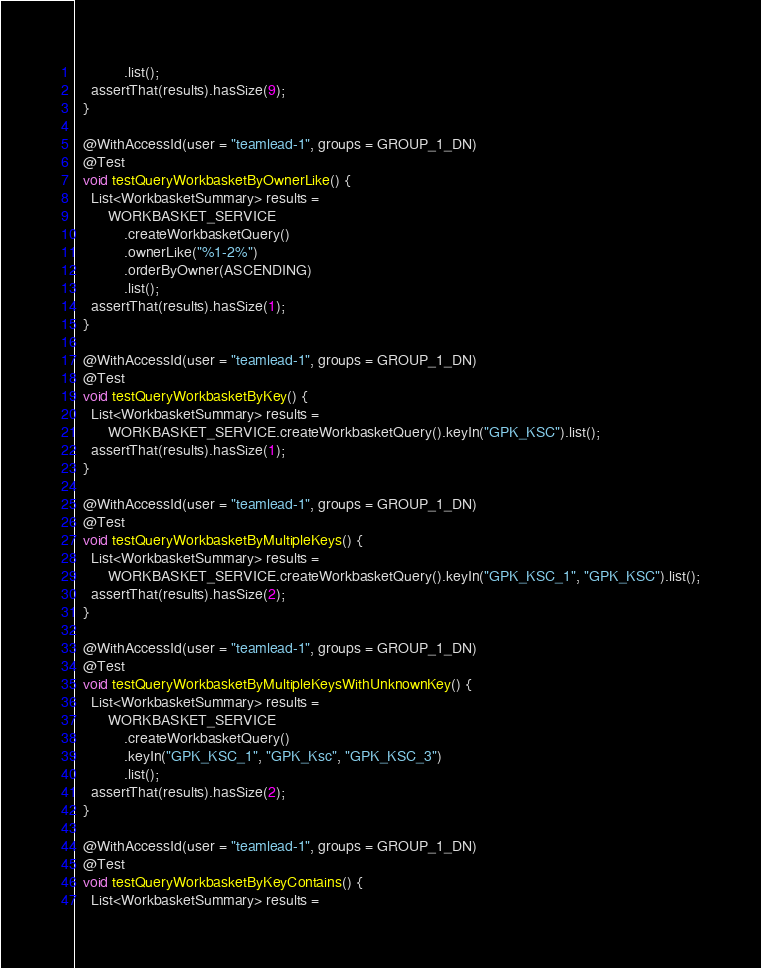<code> <loc_0><loc_0><loc_500><loc_500><_Java_>            .list();
    assertThat(results).hasSize(9);
  }

  @WithAccessId(user = "teamlead-1", groups = GROUP_1_DN)
  @Test
  void testQueryWorkbasketByOwnerLike() {
    List<WorkbasketSummary> results =
        WORKBASKET_SERVICE
            .createWorkbasketQuery()
            .ownerLike("%1-2%")
            .orderByOwner(ASCENDING)
            .list();
    assertThat(results).hasSize(1);
  }

  @WithAccessId(user = "teamlead-1", groups = GROUP_1_DN)
  @Test
  void testQueryWorkbasketByKey() {
    List<WorkbasketSummary> results =
        WORKBASKET_SERVICE.createWorkbasketQuery().keyIn("GPK_KSC").list();
    assertThat(results).hasSize(1);
  }

  @WithAccessId(user = "teamlead-1", groups = GROUP_1_DN)
  @Test
  void testQueryWorkbasketByMultipleKeys() {
    List<WorkbasketSummary> results =
        WORKBASKET_SERVICE.createWorkbasketQuery().keyIn("GPK_KSC_1", "GPK_KSC").list();
    assertThat(results).hasSize(2);
  }

  @WithAccessId(user = "teamlead-1", groups = GROUP_1_DN)
  @Test
  void testQueryWorkbasketByMultipleKeysWithUnknownKey() {
    List<WorkbasketSummary> results =
        WORKBASKET_SERVICE
            .createWorkbasketQuery()
            .keyIn("GPK_KSC_1", "GPK_Ksc", "GPK_KSC_3")
            .list();
    assertThat(results).hasSize(2);
  }

  @WithAccessId(user = "teamlead-1", groups = GROUP_1_DN)
  @Test
  void testQueryWorkbasketByKeyContains() {
    List<WorkbasketSummary> results =</code> 